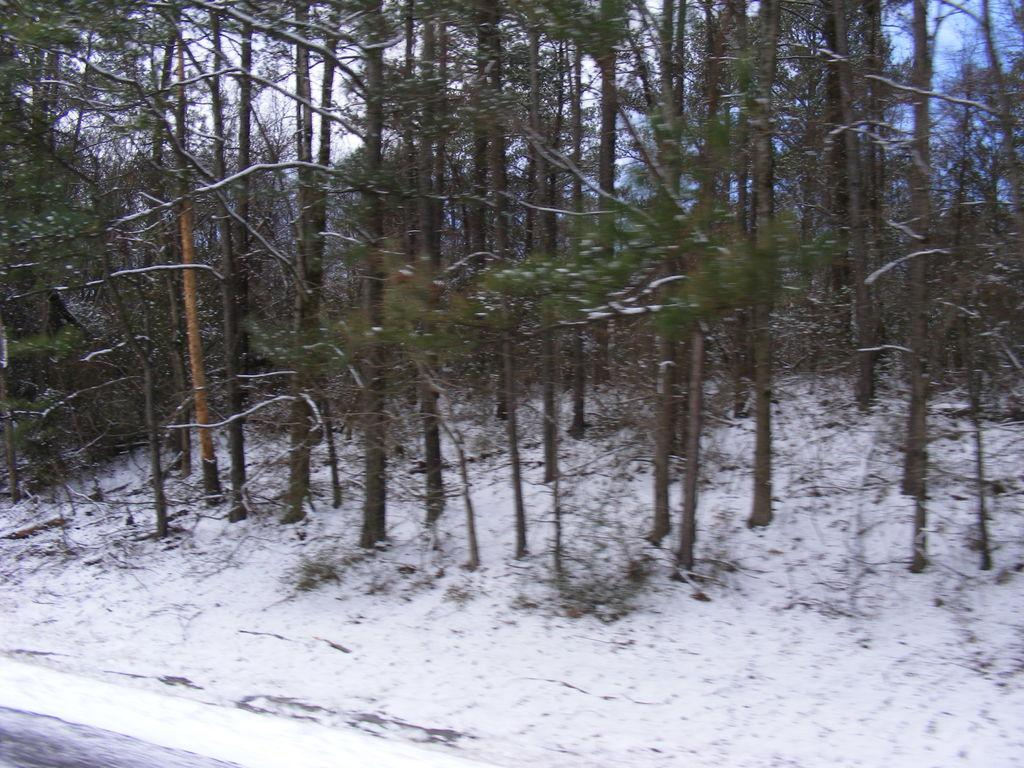What type of vegetation can be seen in the image? There are trees in the image. What is covering the surface at the bottom of the bottom of the image? There is snow on the surface at the bottom of the image. What part of the natural environment is visible at the top? The sky is visible at the top. Can you tell me how many beetles are crawling on the trees in the image? There are no beetles present in the image; it only features trees and snow. What type of wind, zephyr, can be felt in the image? The image does not provide information about the wind or any specific weather conditions, so it is not possible to determine if a zephyr is present. 